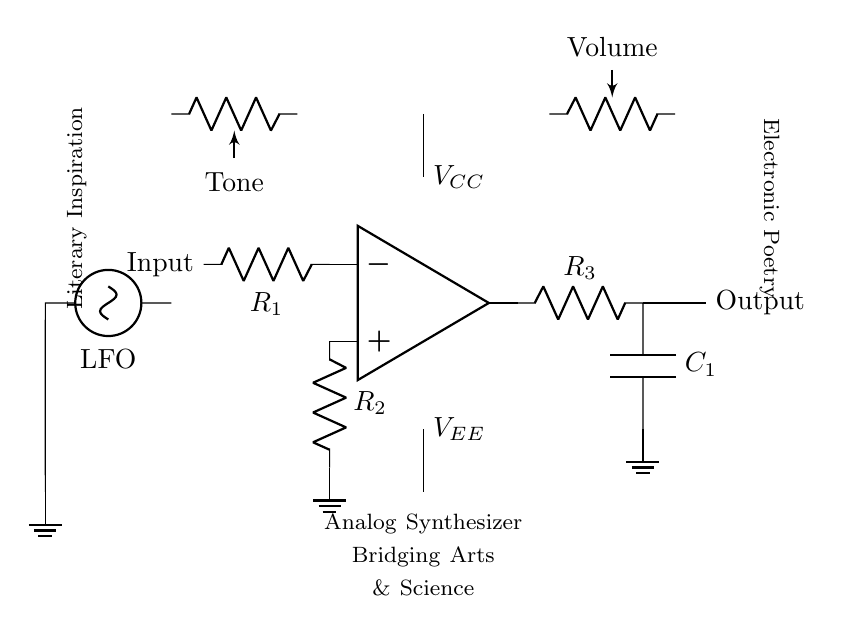What component is connected to the output? The output is connected to a resistor labeled R3.
Answer: R3 What is the value of input voltage? The value of the input voltage is not specified in the diagram, but is provided through both VCC and VEE, functioning to power the operational amplifier.
Answer: Not specified What type of circuit is this? This is an analog synthesizer circuit designed for creating electronic music.
Answer: Analog synthesizer What is the function of the labeled "LFO"? LFO stands for Low-Frequency Oscillator, which generates control signals for varying parameters in the synthesizer circuit.
Answer: Low-Frequency Oscillator How many resistors are present in the circuit? There are three resistors labeled R1, R2, and R3 in the circuit.
Answer: Three What does the output connect to after the resistor? The output connects to a capacitor labeled C1 after the resistor.
Answer: C1 Which literary themes are represented in the circuit? The circuit diagram directly labels components representing "Literary Inspiration" and "Electronic Poetry."
Answer: Literary Inspiration, Electronic Poetry 